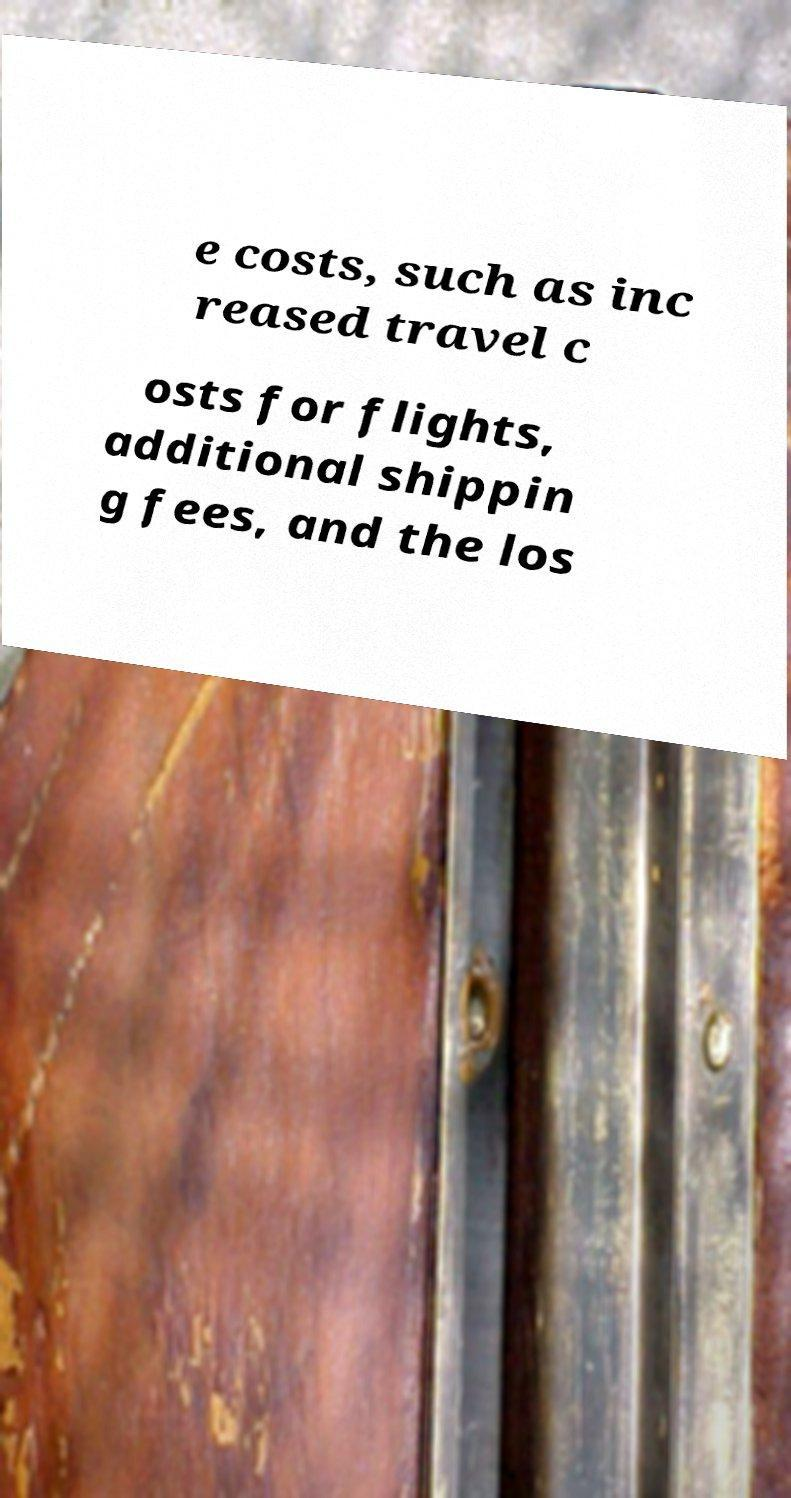I need the written content from this picture converted into text. Can you do that? e costs, such as inc reased travel c osts for flights, additional shippin g fees, and the los 